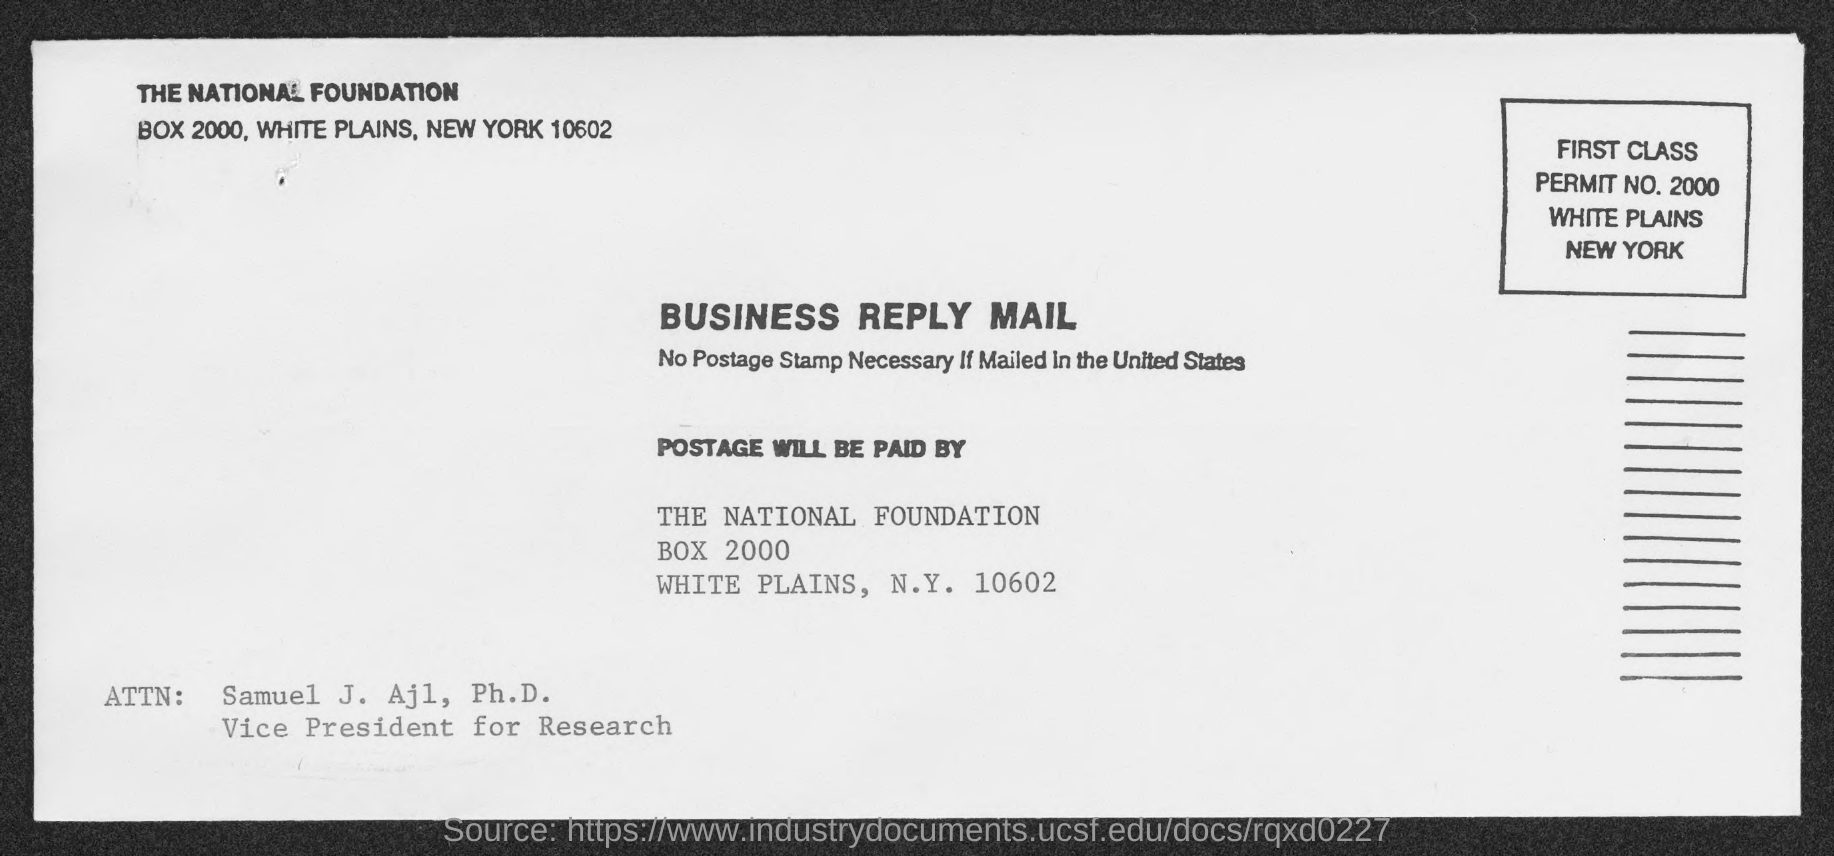Highlight a few significant elements in this photo. Samuel J. Ajl, Ph.D., is the Vice President for Research. 